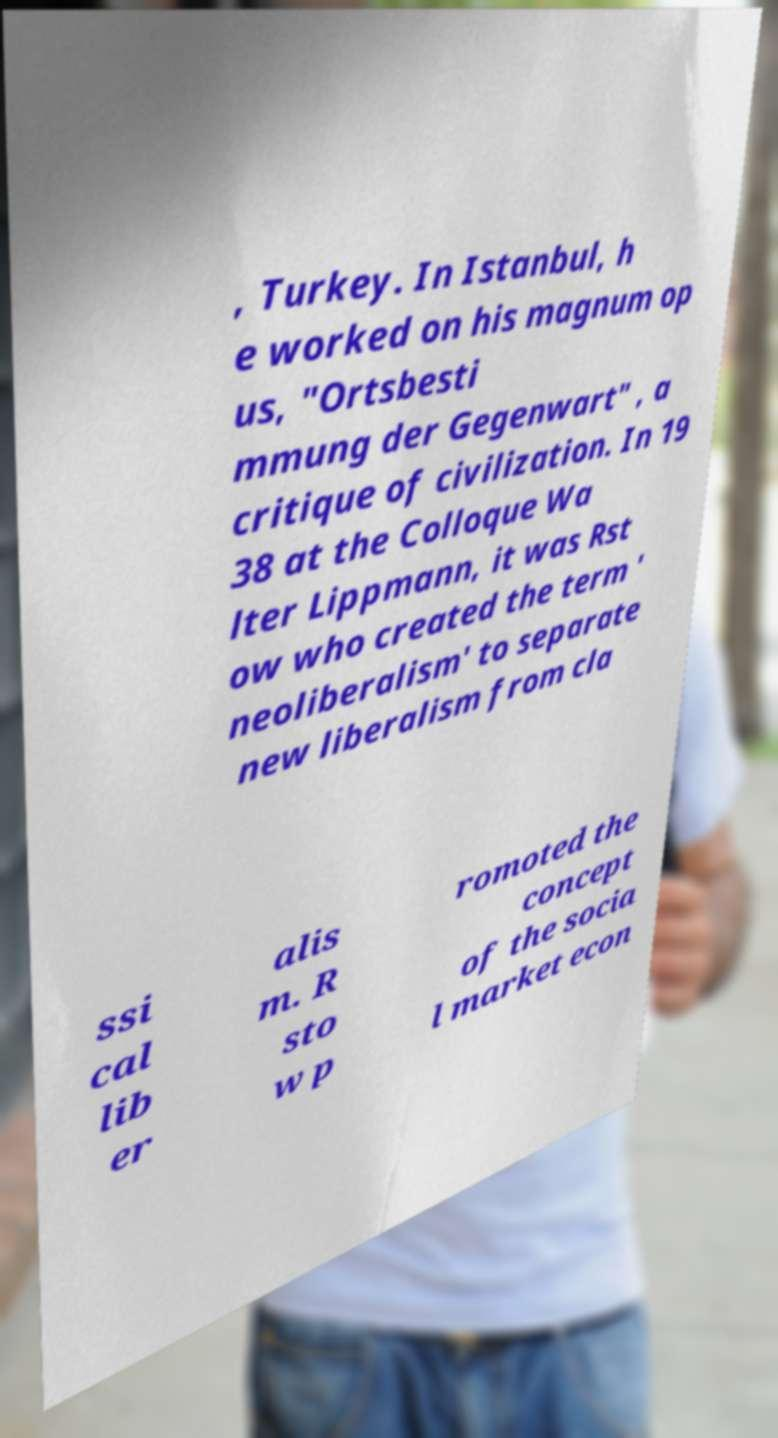Could you extract and type out the text from this image? , Turkey. In Istanbul, h e worked on his magnum op us, "Ortsbesti mmung der Gegenwart" , a critique of civilization. In 19 38 at the Colloque Wa lter Lippmann, it was Rst ow who created the term ' neoliberalism' to separate new liberalism from cla ssi cal lib er alis m. R sto w p romoted the concept of the socia l market econ 